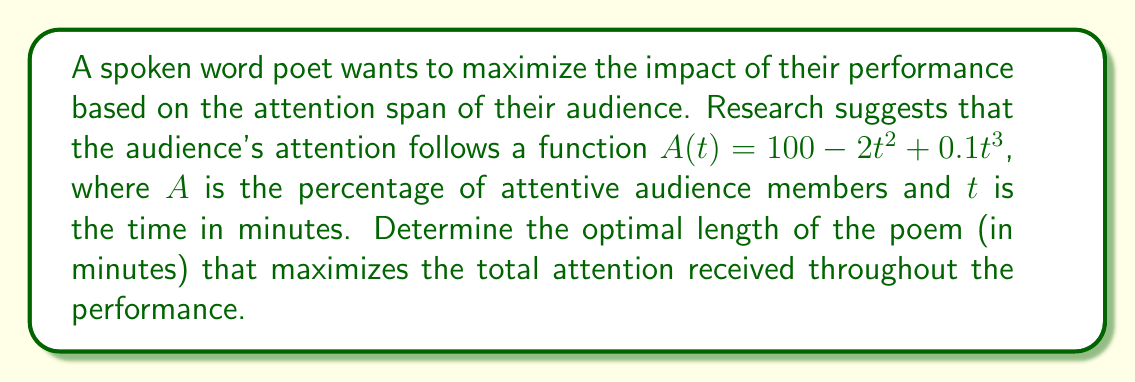Solve this math problem. To solve this problem, we need to find the maximum of the integral of the attention function over time. This will give us the total attention received during the performance.

1) First, let's define the integral that represents the total attention:

   $$T(t) = \int_0^t (100 - 2x^2 + 0.1x^3) dx$$

2) Solve the integral:

   $$T(t) = [100x - \frac{2x^3}{3} + \frac{0.1x^4}{4}]_0^t$$
   $$T(t) = 100t - \frac{2t^3}{3} + \frac{0.1t^4}{4}$$

3) To find the maximum, we need to find where the derivative of $T(t)$ equals zero:

   $$\frac{dT}{dt} = 100 - 2t^2 + 0.1t^3$$

4) Set this equal to zero and solve:

   $$100 - 2t^2 + 0.1t^3 = 0$$

5) This is a cubic equation. It can be solved numerically or by factoring. The solution is approximately:

   $$t \approx 7.86 \text{ minutes}$$

6) To confirm this is a maximum, we can check the second derivative:

   $$\frac{d^2T}{dt^2} = -4t + 0.3t^2$$

   At $t = 7.86$, this is negative, confirming a maximum.

Therefore, the optimal length of the poem to maximize total attention is approximately 7.86 minutes.
Answer: The optimal length of the poem is approximately 7.86 minutes. 